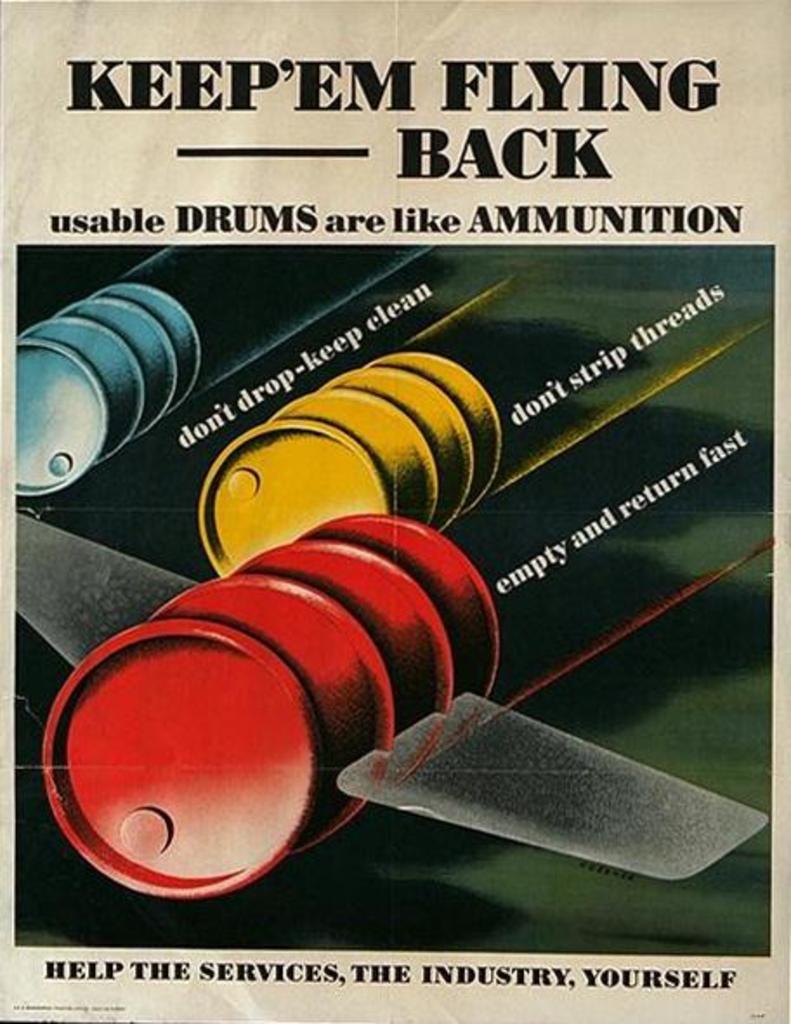Keep em flying which direction?
Offer a terse response. Back. What is like ammunition?
Provide a short and direct response. Usable drums. 